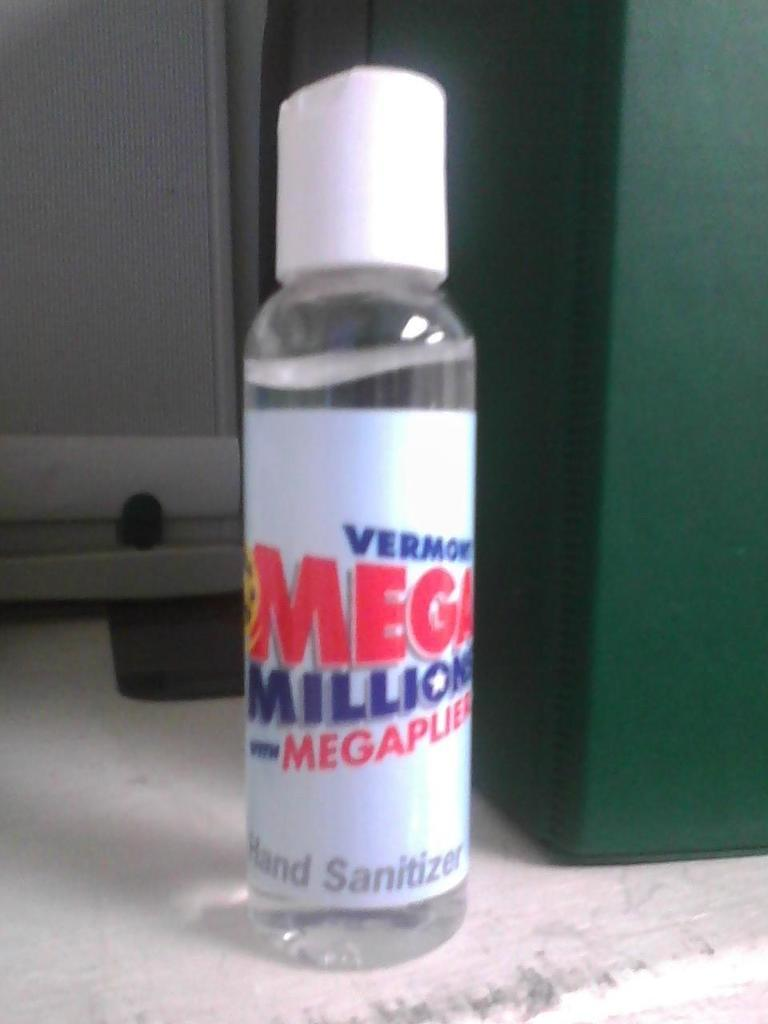<image>
Share a concise interpretation of the image provided. A white and clear bottle of mega millions hand sanitizer 